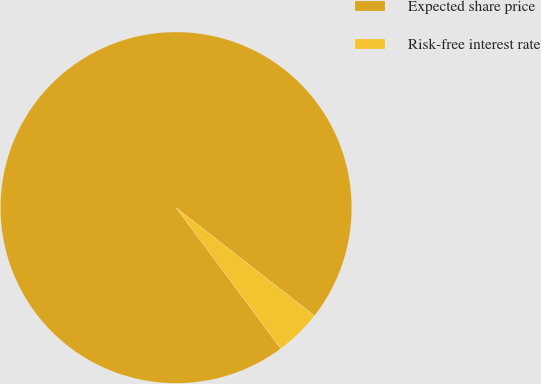Convert chart to OTSL. <chart><loc_0><loc_0><loc_500><loc_500><pie_chart><fcel>Expected share price<fcel>Risk-free interest rate<nl><fcel>95.72%<fcel>4.28%<nl></chart> 